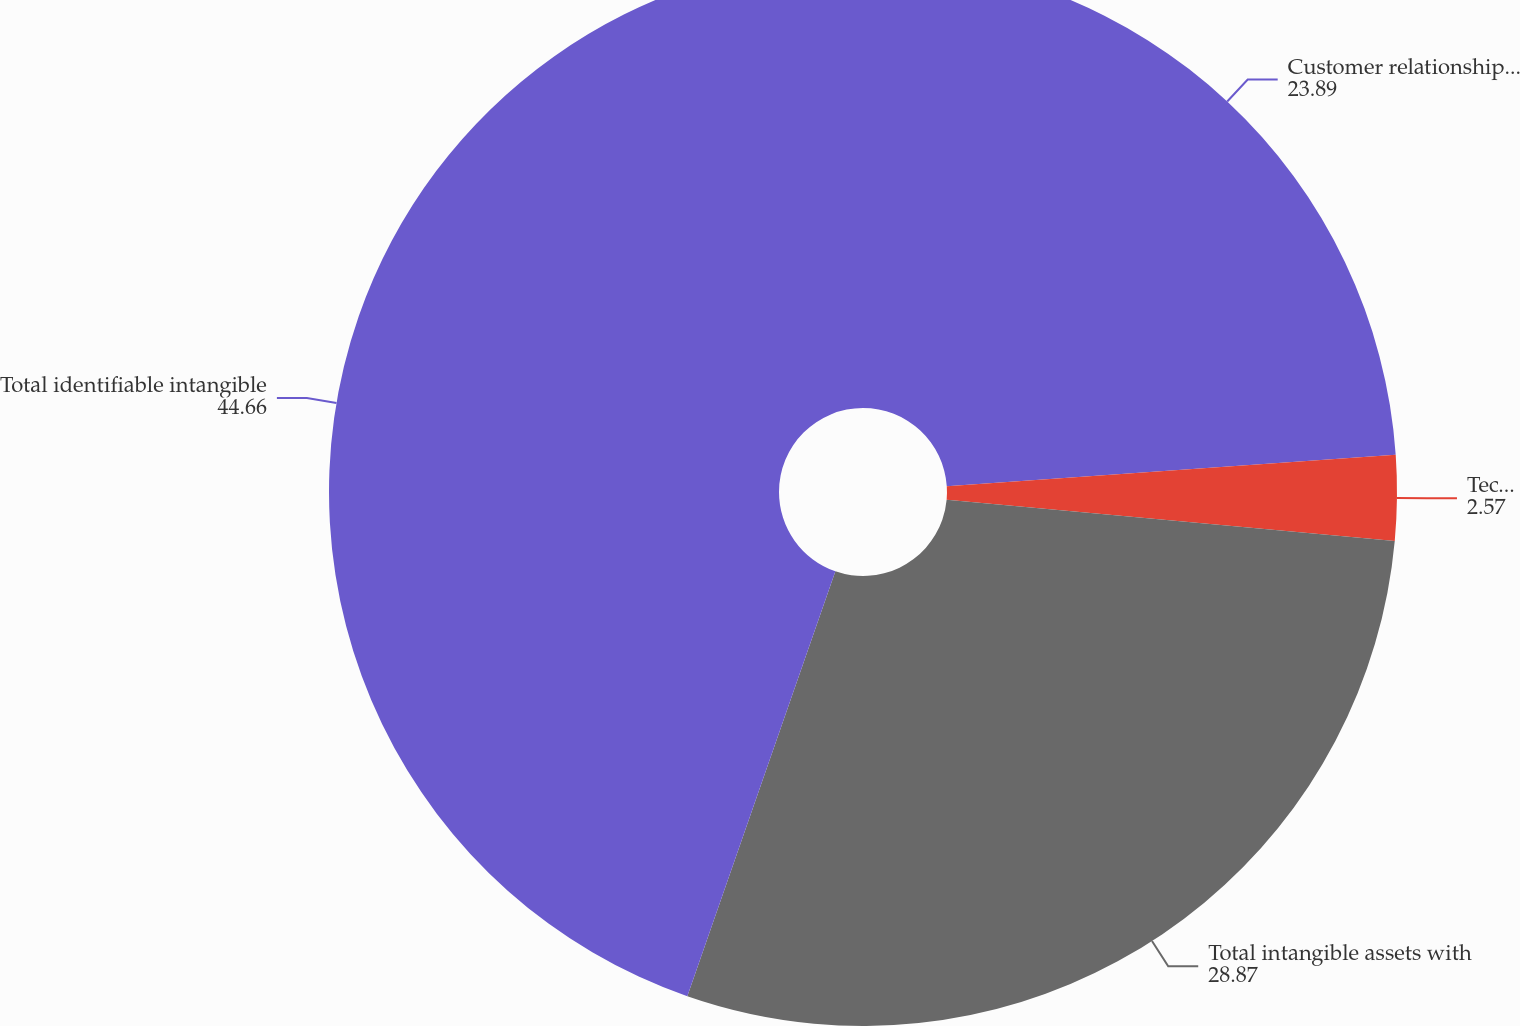Convert chart. <chart><loc_0><loc_0><loc_500><loc_500><pie_chart><fcel>Customer relationships^(1)<fcel>Technology<fcel>Total intangible assets with<fcel>Total identifiable intangible<nl><fcel>23.89%<fcel>2.57%<fcel>28.87%<fcel>44.66%<nl></chart> 